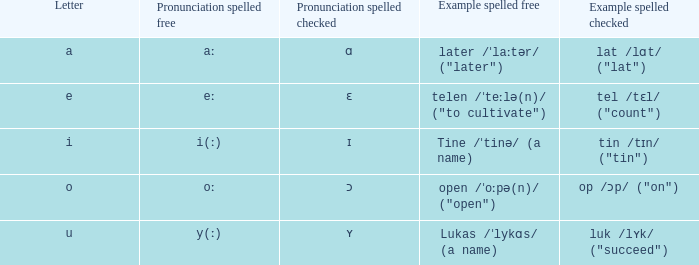What is Pronunciation Spelled Free, when Pronunciation Spelled Checked is "ɑ"? Aː. 